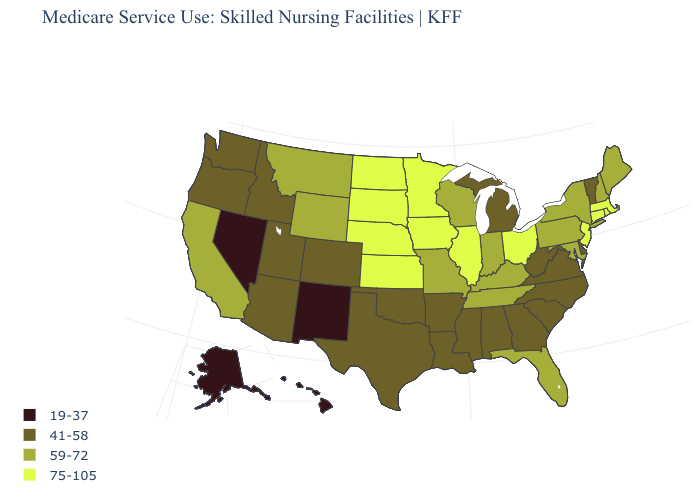Among the states that border New Hampshire , which have the highest value?
Quick response, please. Massachusetts. What is the value of California?
Answer briefly. 59-72. Does Indiana have the highest value in the MidWest?
Be succinct. No. What is the value of Wisconsin?
Answer briefly. 59-72. What is the lowest value in the Northeast?
Be succinct. 41-58. Which states have the lowest value in the USA?
Answer briefly. Alaska, Hawaii, Nevada, New Mexico. Among the states that border Wisconsin , does Michigan have the highest value?
Give a very brief answer. No. Which states have the lowest value in the Northeast?
Answer briefly. Vermont. What is the value of Rhode Island?
Write a very short answer. 75-105. Name the states that have a value in the range 41-58?
Write a very short answer. Alabama, Arizona, Arkansas, Colorado, Delaware, Georgia, Idaho, Louisiana, Michigan, Mississippi, North Carolina, Oklahoma, Oregon, South Carolina, Texas, Utah, Vermont, Virginia, Washington, West Virginia. What is the value of Indiana?
Answer briefly. 59-72. Which states have the highest value in the USA?
Quick response, please. Connecticut, Illinois, Iowa, Kansas, Massachusetts, Minnesota, Nebraska, New Jersey, North Dakota, Ohio, Rhode Island, South Dakota. What is the value of Indiana?
Quick response, please. 59-72. What is the value of California?
Write a very short answer. 59-72. 